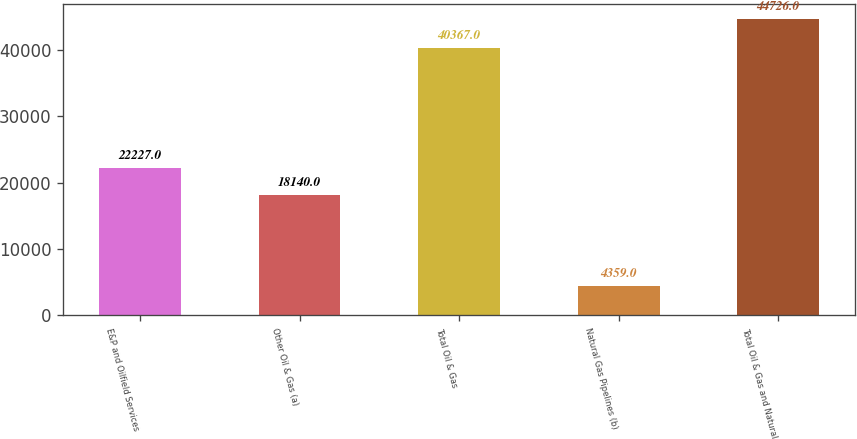Convert chart to OTSL. <chart><loc_0><loc_0><loc_500><loc_500><bar_chart><fcel>E&P and Oilfield Services<fcel>Other Oil & Gas (a)<fcel>Total Oil & Gas<fcel>Natural Gas Pipelines (b)<fcel>Total Oil & Gas and Natural<nl><fcel>22227<fcel>18140<fcel>40367<fcel>4359<fcel>44726<nl></chart> 